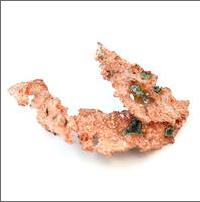Is native copper a mineral? Yes, native copper is classified as a mineral. A substance qualifies as a mineral if it adheres to the following criteria: it must be a solid, occur naturally, not be manufactured by biological processes, consist of a single chemical compound, and have a definitive crystal structure. Native copper meets all these terms, showcasing characteristics like distinctive reddish-brown metallic luster and malleability that make it identifiable. 